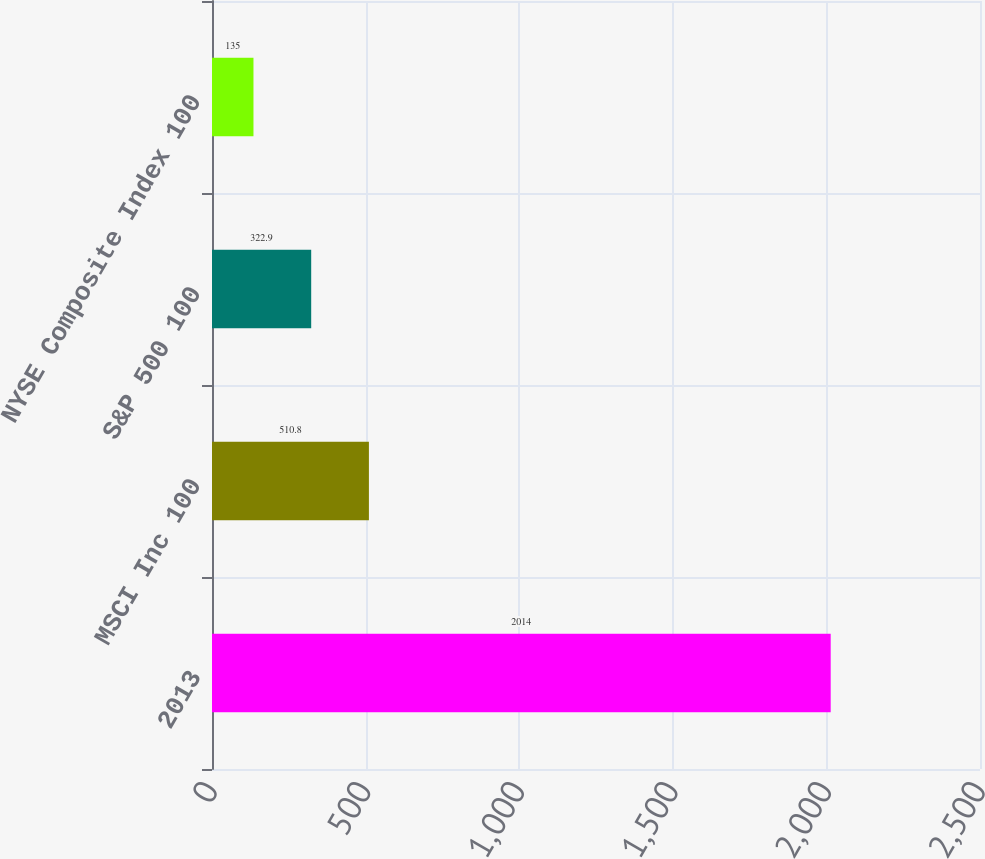<chart> <loc_0><loc_0><loc_500><loc_500><bar_chart><fcel>2013<fcel>MSCI Inc 100<fcel>S&P 500 100<fcel>NYSE Composite Index 100<nl><fcel>2014<fcel>510.8<fcel>322.9<fcel>135<nl></chart> 